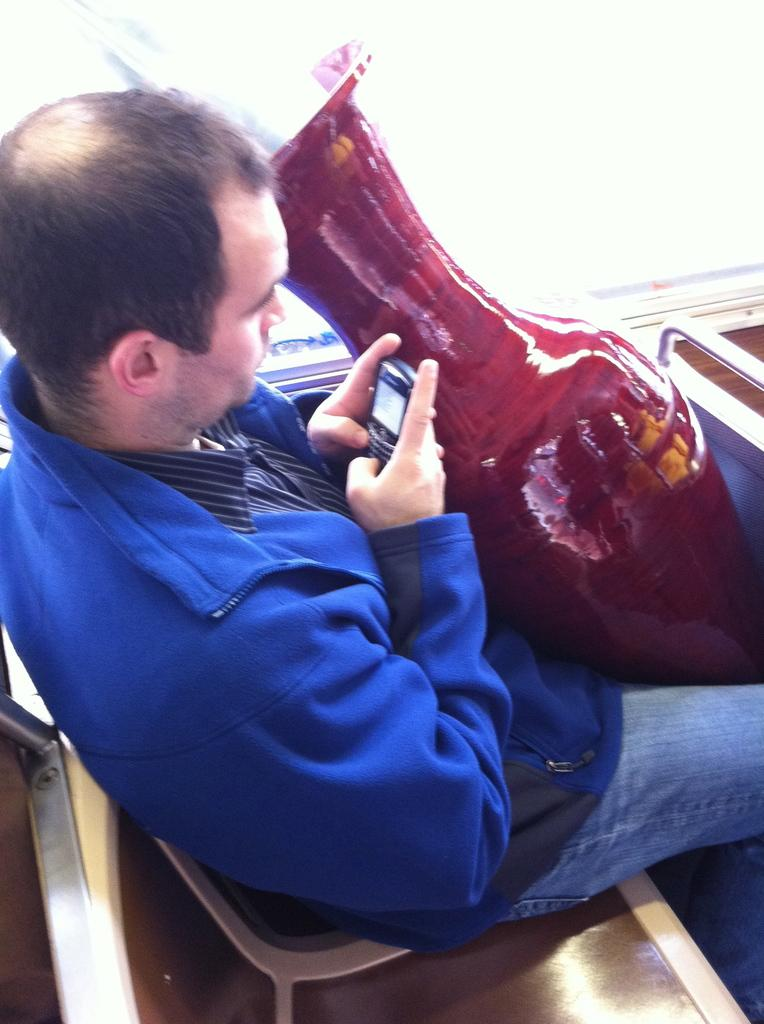Who is present in the image? There is a man in the image. What is the man doing in the image? The man is seated on a chair in the image. What object is the man holding in his hand? The man is holding a mobile in his hand. What can be seen in front of the man? There is a flower vase in front of the man. What type of bead is the man using to force attention in the image? There is no bead or any indication of the man trying to force attention in the image. 